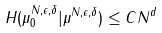<formula> <loc_0><loc_0><loc_500><loc_500>H ( \mu _ { 0 } ^ { N , \epsilon , \delta } | \mu ^ { N , \epsilon , \delta } ) \leq C N ^ { d }</formula> 